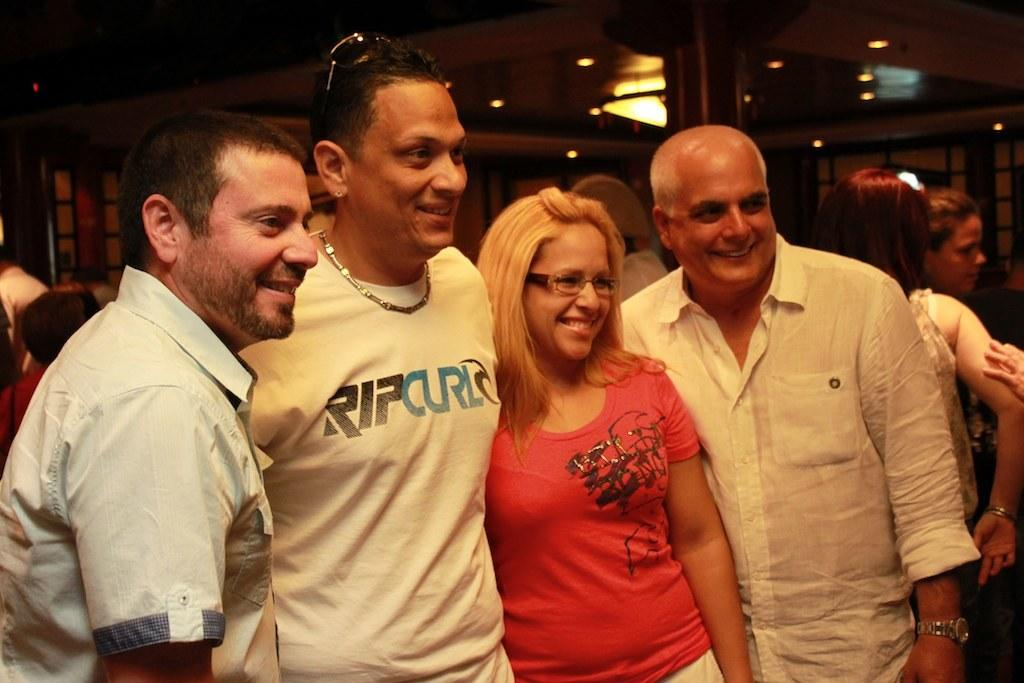What is happening in the image? There is a group of persons standing on the floor. Can you describe any specific details about one of the persons in the group? One woman in the group is wearing spectacles and a red t-shirt. What can be seen in the background of the image? There are lights visible in the background. How many apples are being delivered to the group in the image? There is no mention of apples or a delivery in the image. 